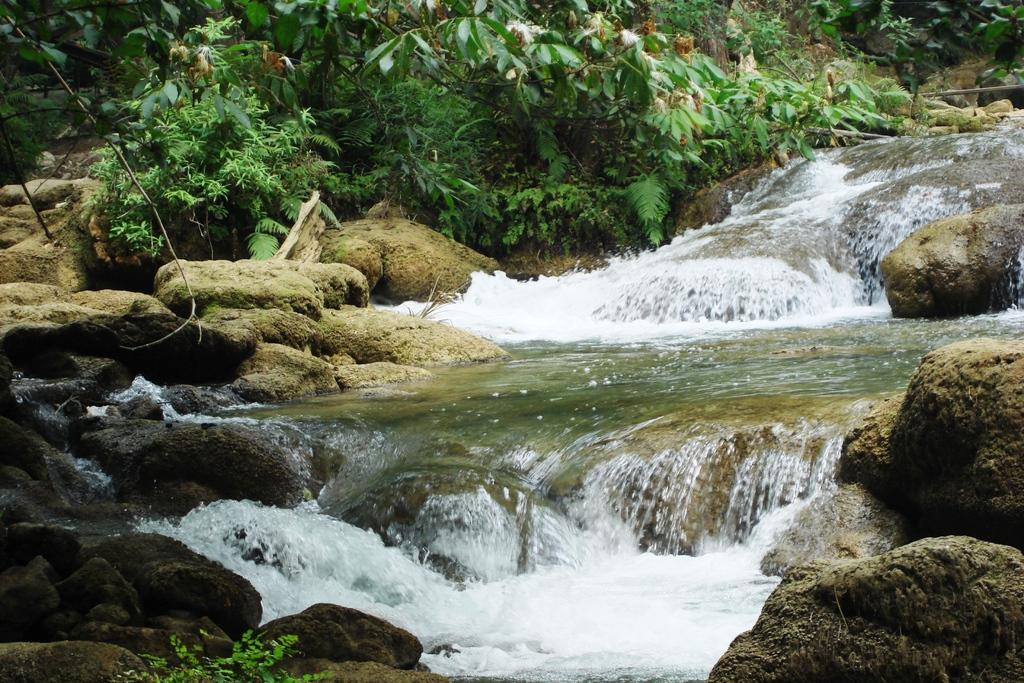What is visible in the image? Water and rocks are visible in the image. What can be seen in the background of the image? There are trees in the background of the image. How many brothers are playing in the group during recess in the image? There is no reference to brothers, a group, or recess in the image. 